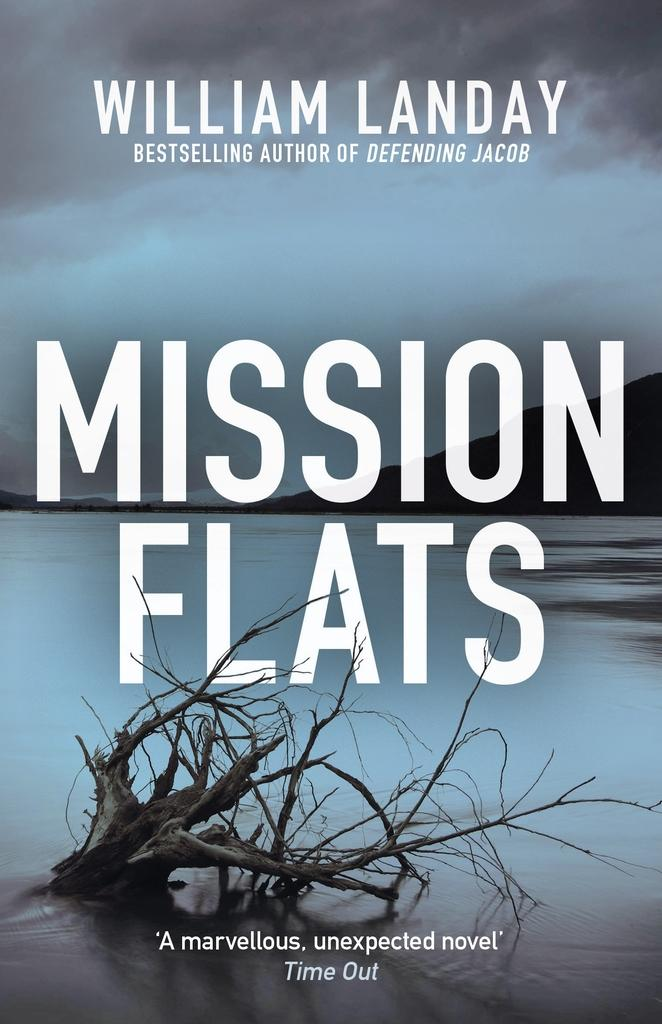Provide a one-sentence caption for the provided image. A book by William Landy entitled Misson Flats. 